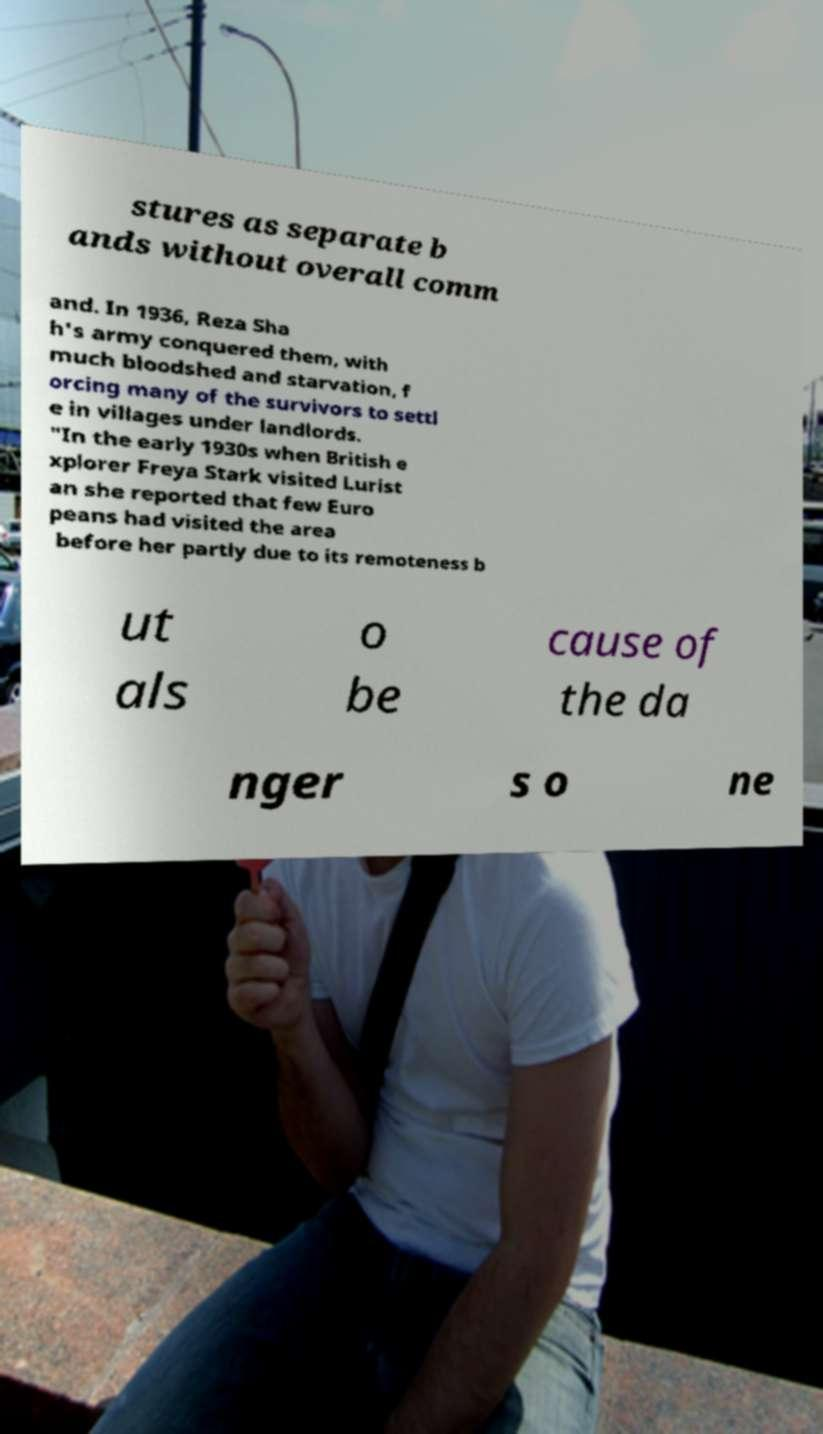What messages or text are displayed in this image? I need them in a readable, typed format. stures as separate b ands without overall comm and. In 1936, Reza Sha h's army conquered them, with much bloodshed and starvation, f orcing many of the survivors to settl e in villages under landlords. "In the early 1930s when British e xplorer Freya Stark visited Lurist an she reported that few Euro peans had visited the area before her partly due to its remoteness b ut als o be cause of the da nger s o ne 